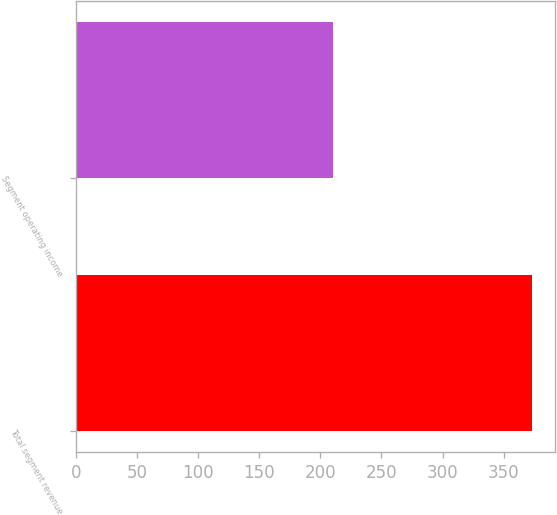Convert chart to OTSL. <chart><loc_0><loc_0><loc_500><loc_500><bar_chart><fcel>Total segment revenue<fcel>Segment operating income<nl><fcel>373<fcel>210<nl></chart> 